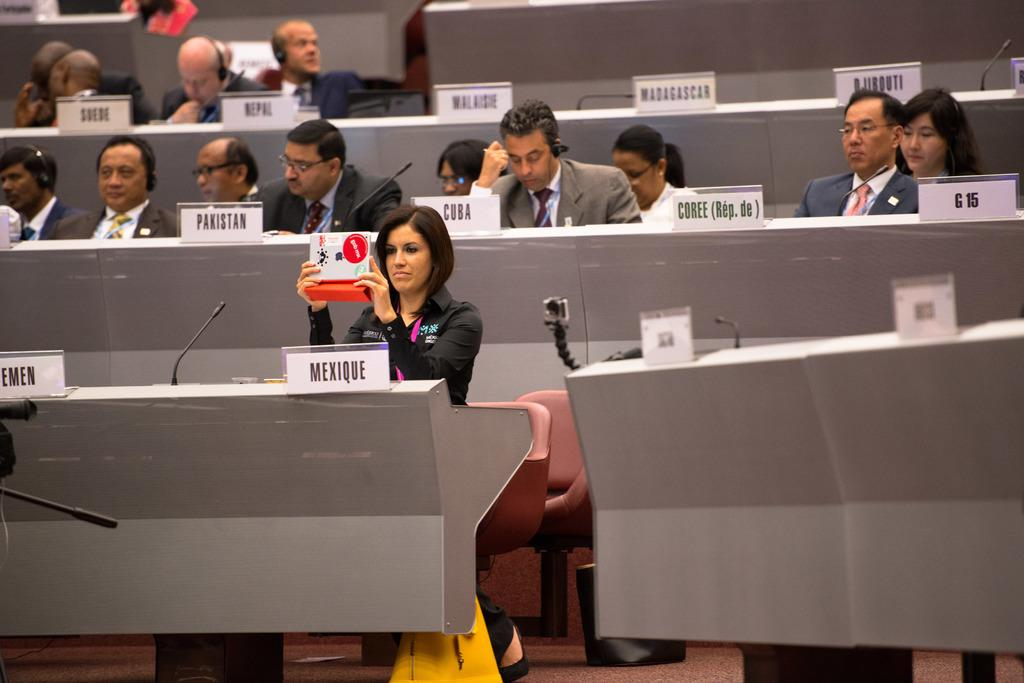What are the people in the image doing? The people in the image are sitting on chairs. Can you describe what one of the people is holding? There is a person holding an object in the image. What type of equipment is visible in the image? Microphones are visible in the image. What is written on the tables in the image? Name boards are present on the tables in the image. What type of surface is visible in the image? The image shows a floor. What type of comb is being used by the laborer in the image? There is no laborer or comb present in the image. What religious belief is being practiced by the people in the image? There is no indication of any religious belief being practiced in the image. 